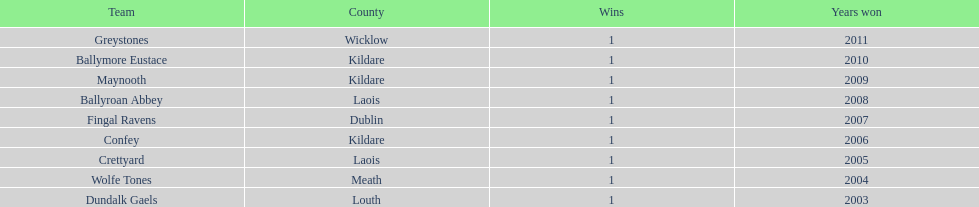Can you parse all the data within this table? {'header': ['Team', 'County', 'Wins', 'Years won'], 'rows': [['Greystones', 'Wicklow', '1', '2011'], ['Ballymore Eustace', 'Kildare', '1', '2010'], ['Maynooth', 'Kildare', '1', '2009'], ['Ballyroan Abbey', 'Laois', '1', '2008'], ['Fingal Ravens', 'Dublin', '1', '2007'], ['Confey', 'Kildare', '1', '2006'], ['Crettyard', 'Laois', '1', '2005'], ['Wolfe Tones', 'Meath', '1', '2004'], ['Dundalk Gaels', 'Louth', '1', '2003']]} What is the difference years won for crettyard and greystones 6. 